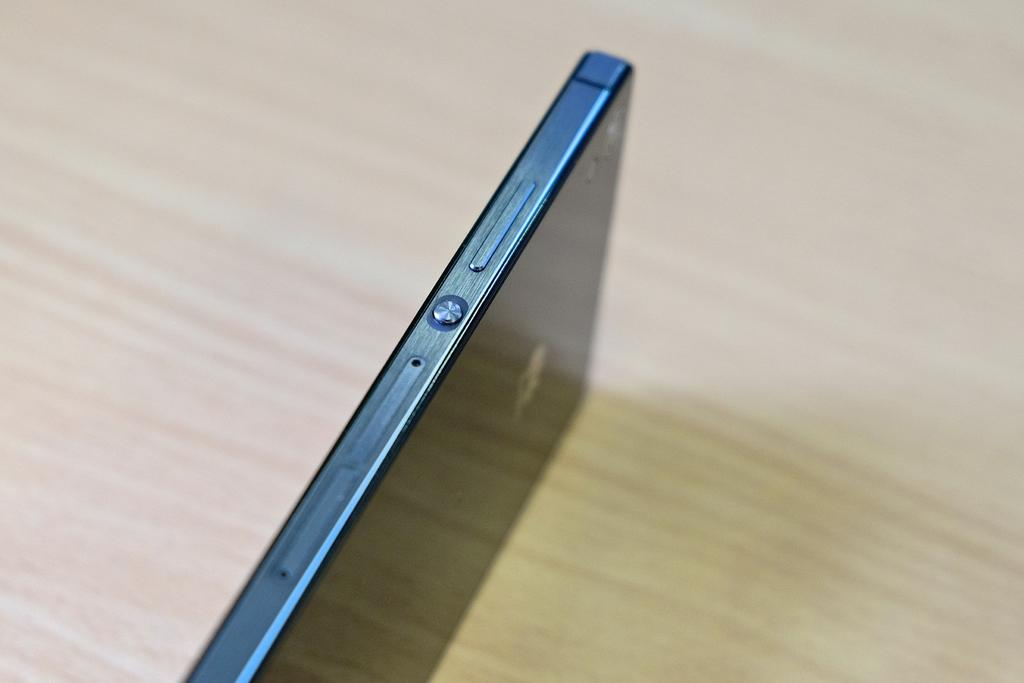What electronic device can be seen in the image? There is a mobile phone on a surface in the image. Can you describe the position of the mobile phone in the image? The mobile phone is on a surface in the image. What might the mobile phone be used for in the image? The mobile phone could be used for communication, browsing the internet, or taking photos, among other functions. How many tomatoes are on the mobile phone in the image? There are no tomatoes present on the mobile phone in the image. What type of cattle can be seen grazing near the mobile phone in the image? There are no cattle present in the image, as it only features a mobile phone on a surface. 